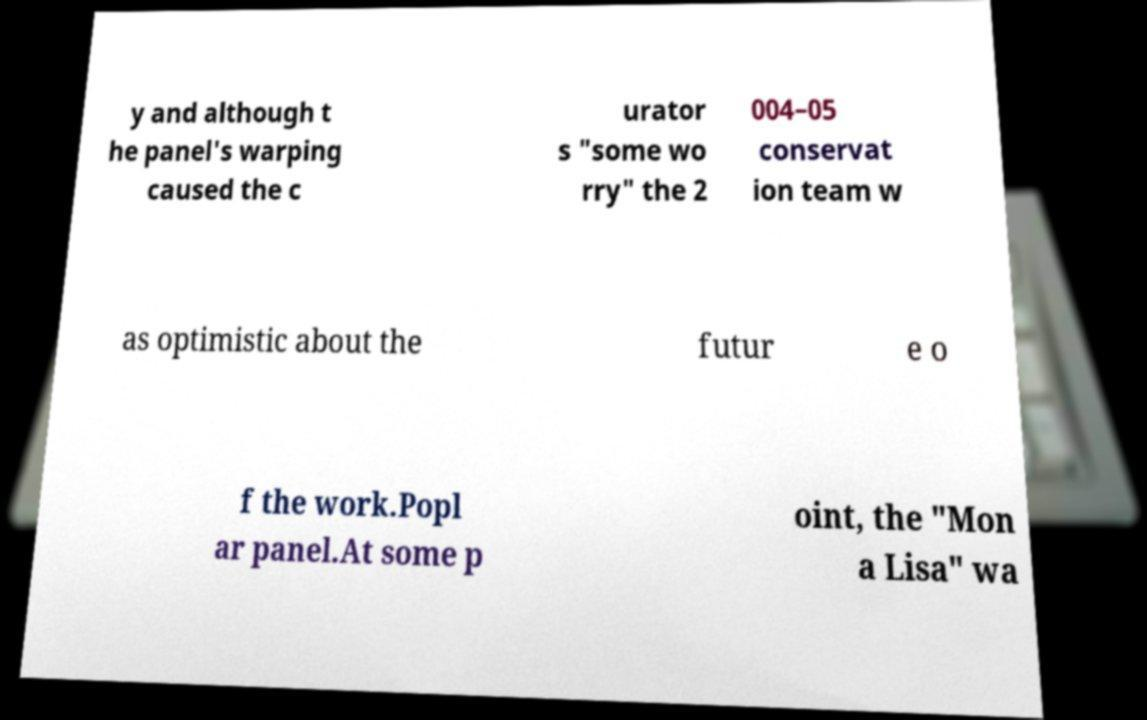Please identify and transcribe the text found in this image. y and although t he panel's warping caused the c urator s "some wo rry" the 2 004–05 conservat ion team w as optimistic about the futur e o f the work.Popl ar panel.At some p oint, the "Mon a Lisa" wa 